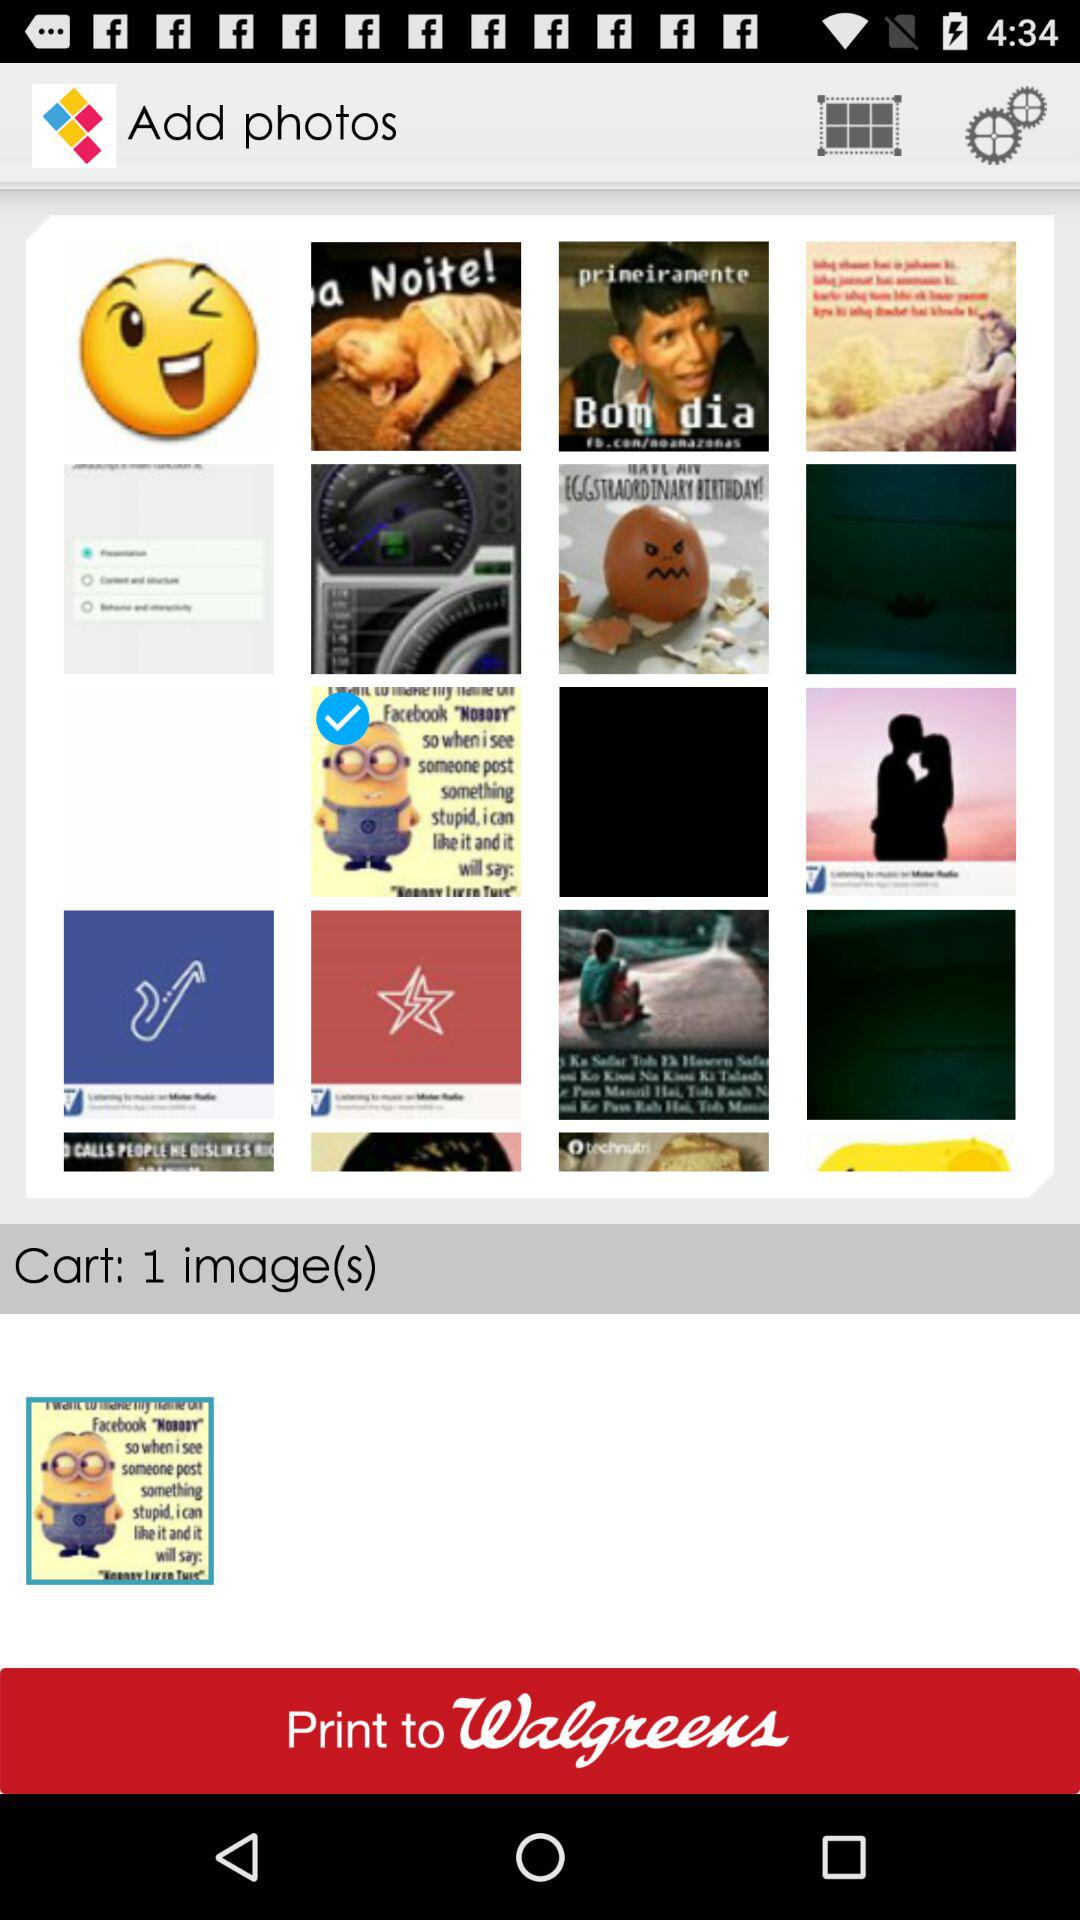How many notifications are there in the settings?
When the provided information is insufficient, respond with <no answer>. <no answer> 